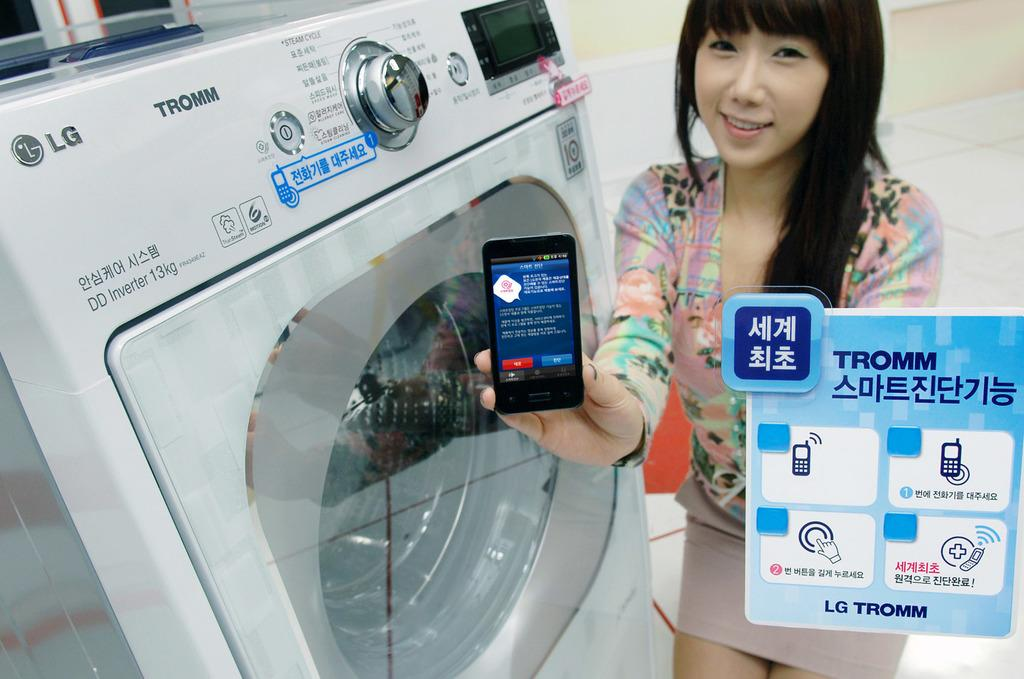<image>
Provide a brief description of the given image. A woman holding a cell phone while standing next to a washing machine that says TROMM. 